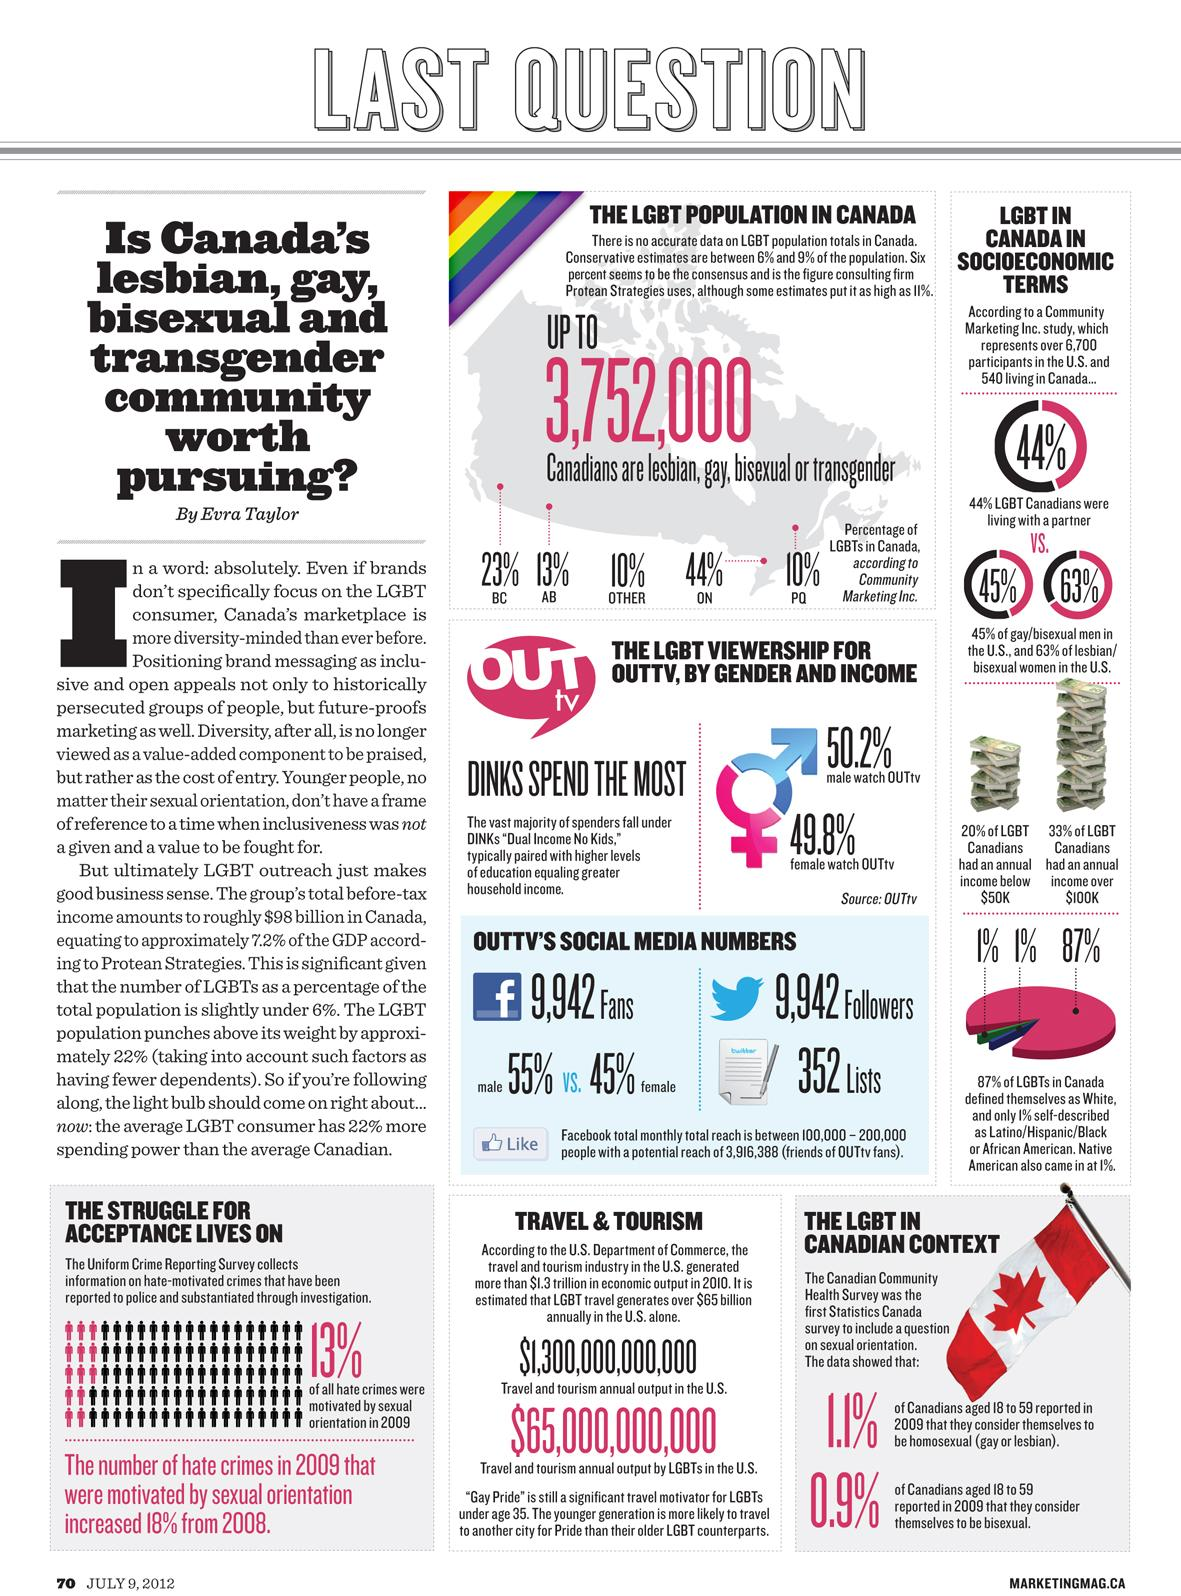Outline some significant characteristics in this image. OUTtv is watched more frequently by males. 